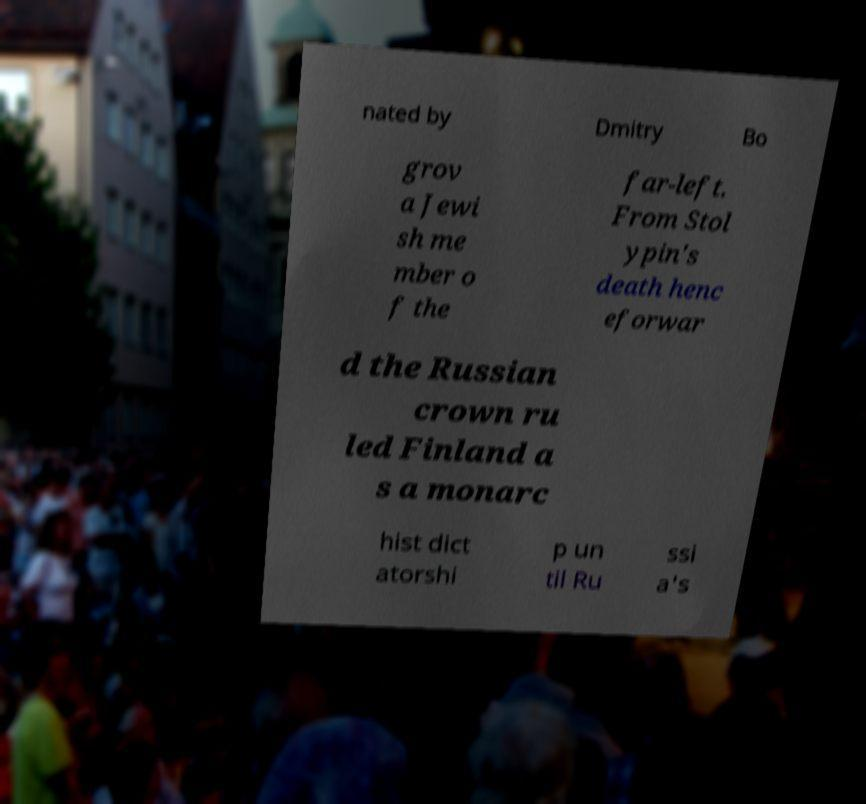Can you read and provide the text displayed in the image?This photo seems to have some interesting text. Can you extract and type it out for me? nated by Dmitry Bo grov a Jewi sh me mber o f the far-left. From Stol ypin's death henc eforwar d the Russian crown ru led Finland a s a monarc hist dict atorshi p un til Ru ssi a's 